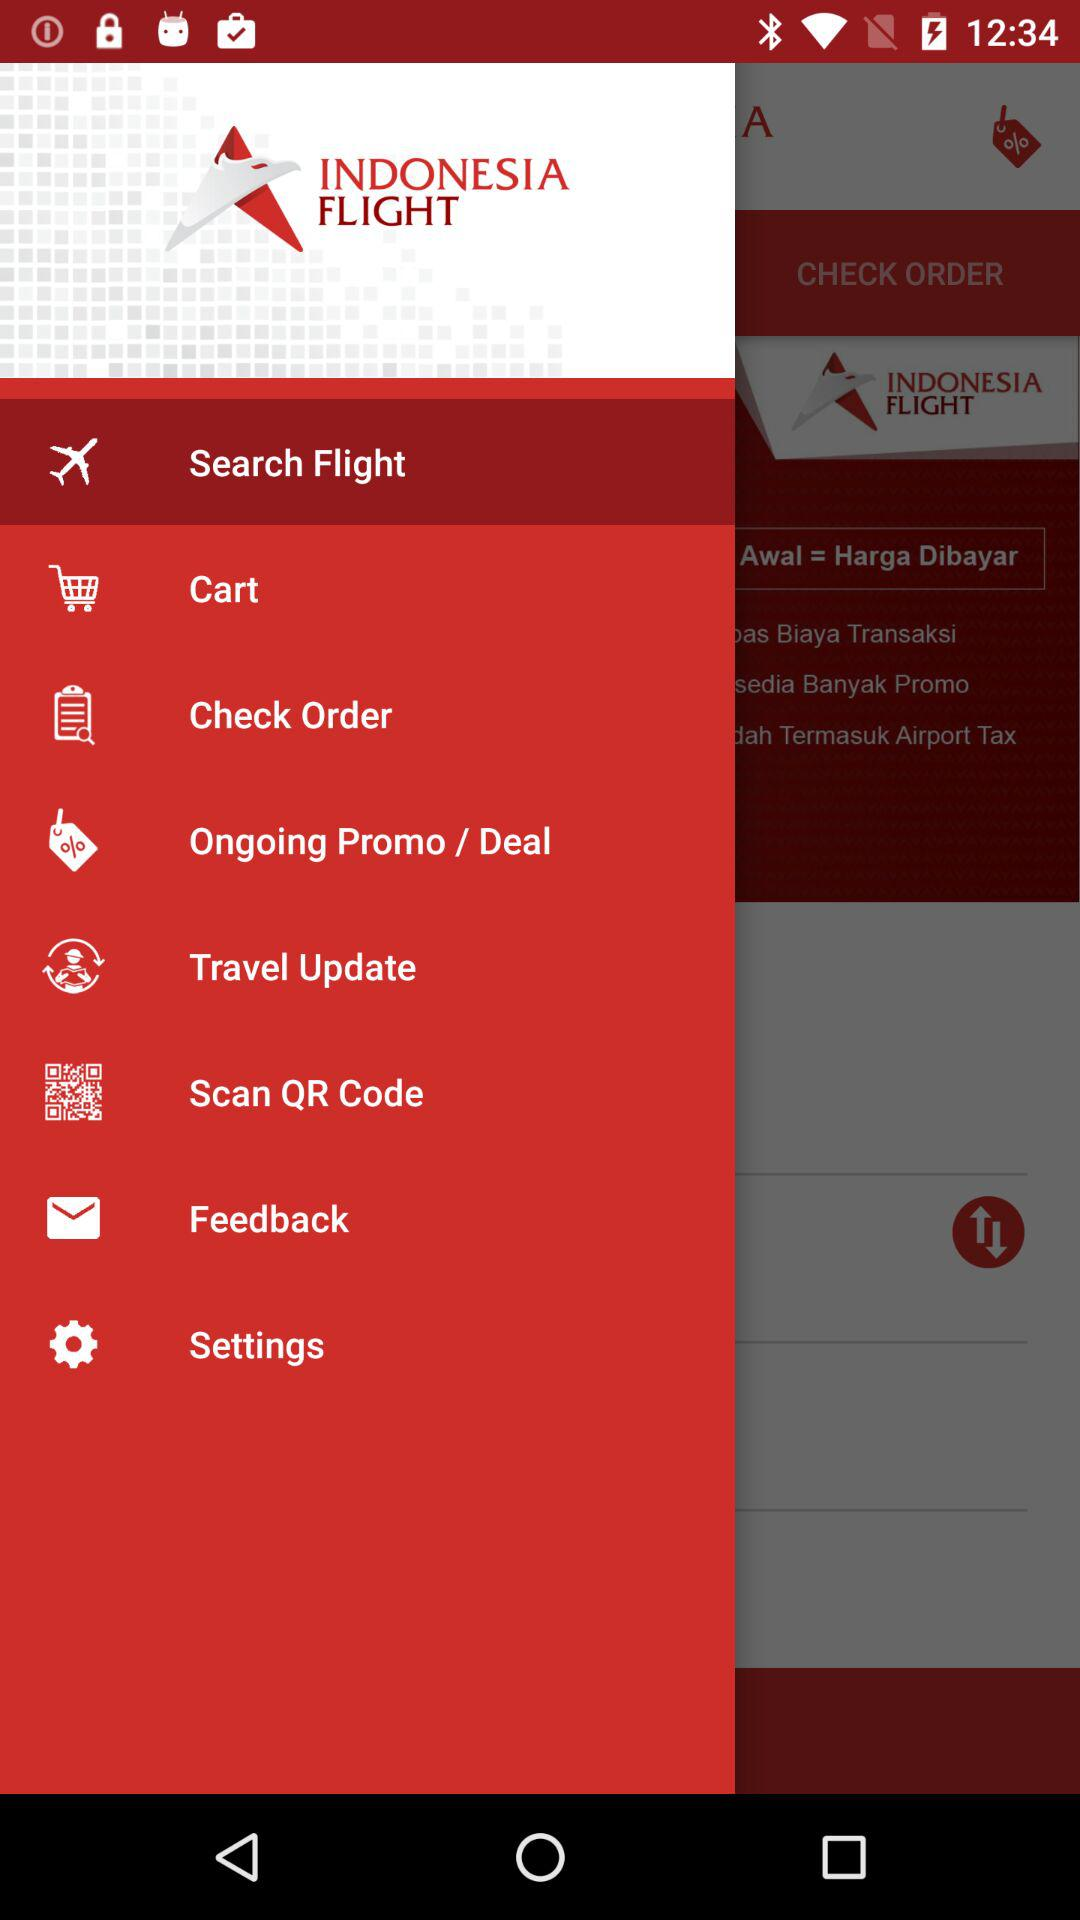How many languages are available in the language setting?
Answer the question using a single word or phrase. 2 